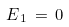Convert formula to latex. <formula><loc_0><loc_0><loc_500><loc_500>E _ { \, 1 } \, = \, 0</formula> 